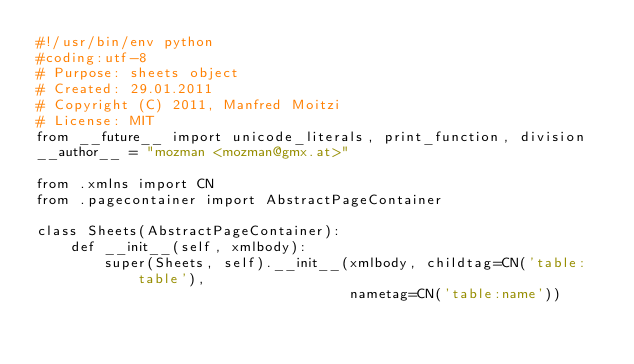<code> <loc_0><loc_0><loc_500><loc_500><_Python_>#!/usr/bin/env python
#coding:utf-8
# Purpose: sheets object
# Created: 29.01.2011
# Copyright (C) 2011, Manfred Moitzi
# License: MIT
from __future__ import unicode_literals, print_function, division
__author__ = "mozman <mozman@gmx.at>"

from .xmlns import CN
from .pagecontainer import AbstractPageContainer

class Sheets(AbstractPageContainer):
    def __init__(self, xmlbody):
        super(Sheets, self).__init__(xmlbody, childtag=CN('table:table'),
                                     nametag=CN('table:name'))

</code> 